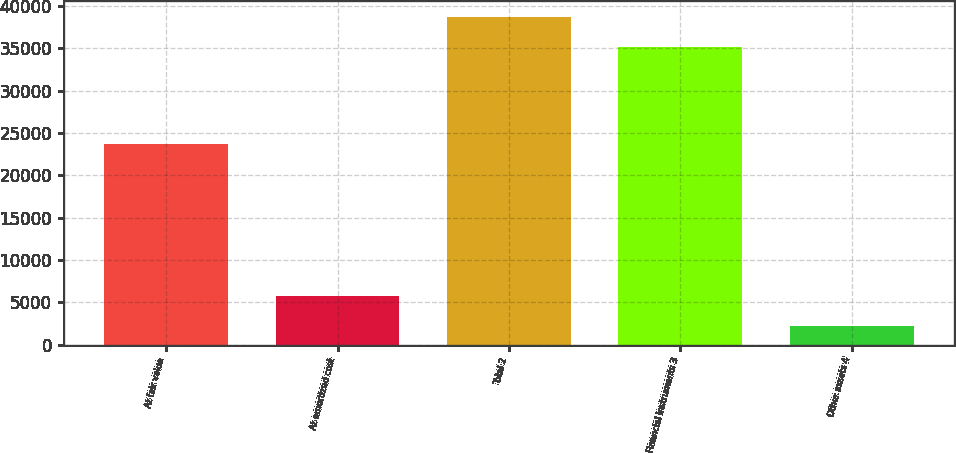Convert chart. <chart><loc_0><loc_0><loc_500><loc_500><bar_chart><fcel>At fair value<fcel>At amortized cost<fcel>Total 2<fcel>Financial instruments 3<fcel>Other assets 4<nl><fcel>23659<fcel>5752.4<fcel>38636.4<fcel>35124<fcel>2240<nl></chart> 